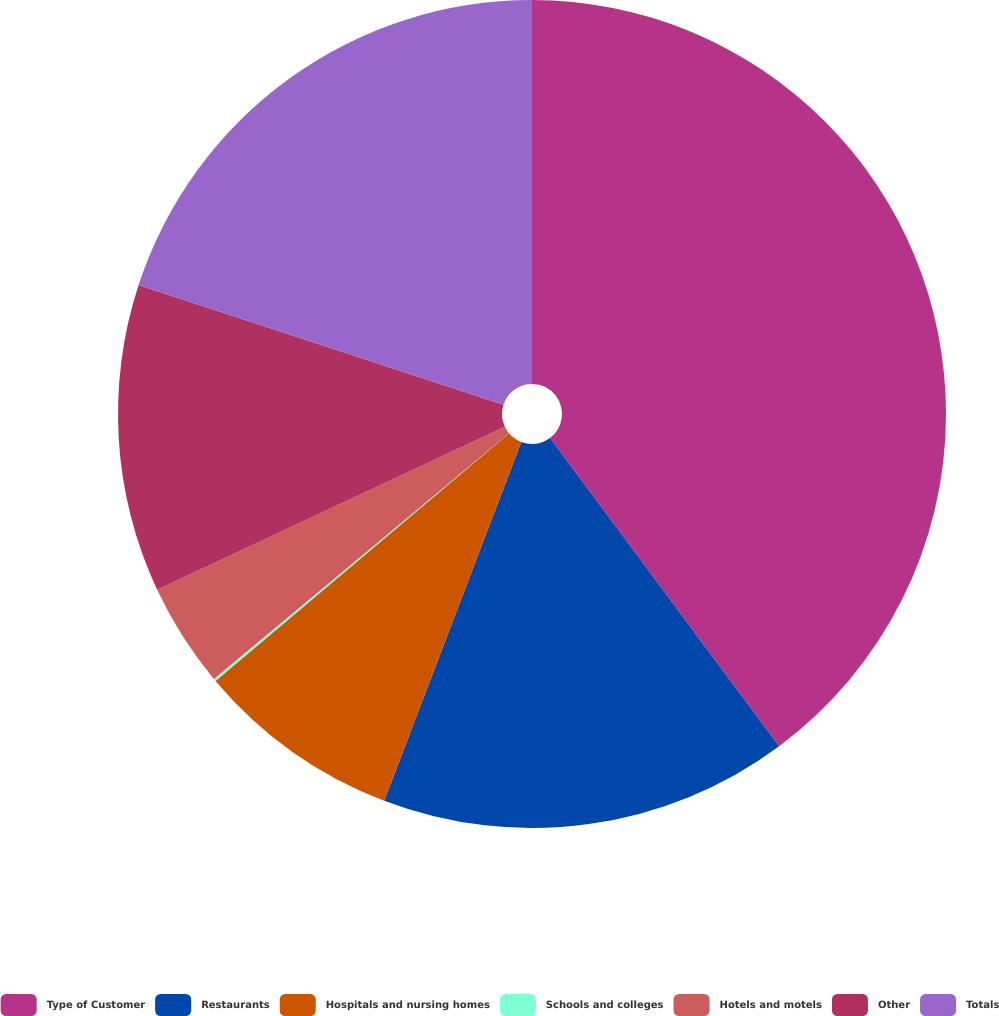Convert chart. <chart><loc_0><loc_0><loc_500><loc_500><pie_chart><fcel>Type of Customer<fcel>Restaurants<fcel>Hospitals and nursing homes<fcel>Schools and colleges<fcel>Hotels and motels<fcel>Other<fcel>Totals<nl><fcel>39.82%<fcel>15.99%<fcel>8.04%<fcel>0.1%<fcel>4.07%<fcel>12.02%<fcel>19.96%<nl></chart> 